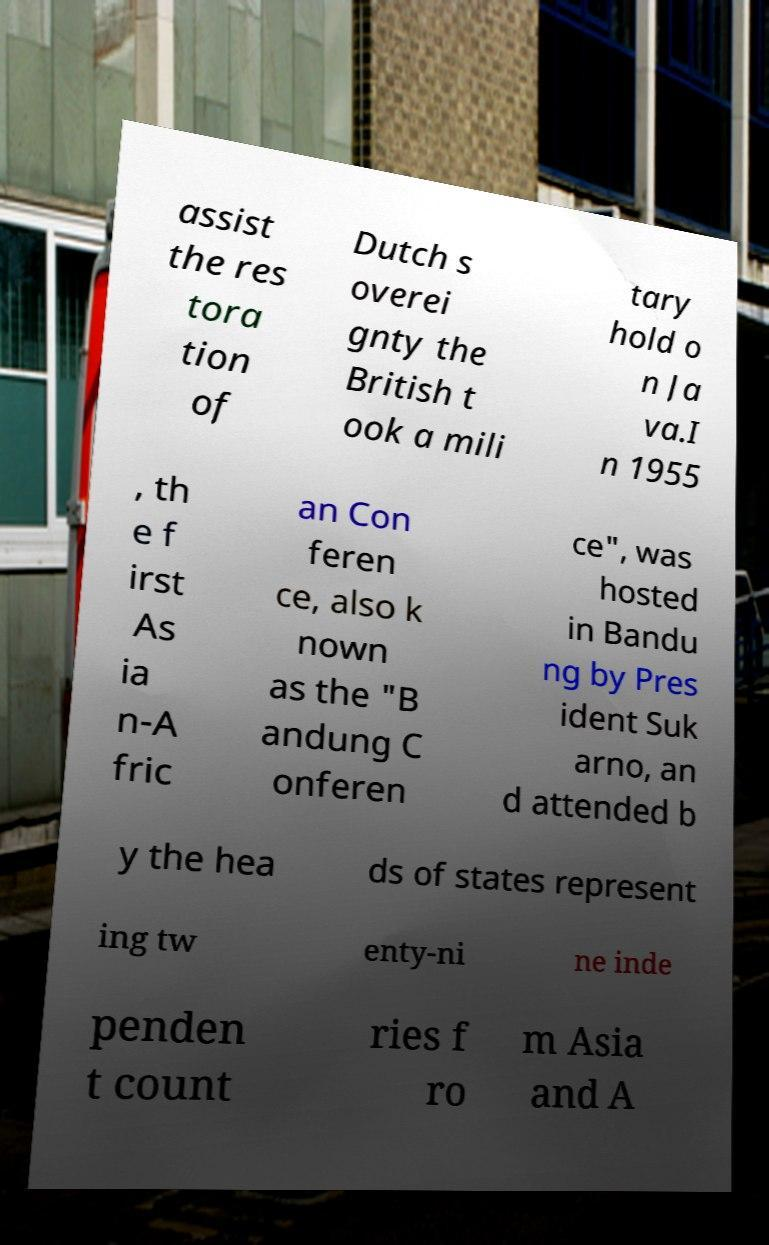Please identify and transcribe the text found in this image. assist the res tora tion of Dutch s overei gnty the British t ook a mili tary hold o n Ja va.I n 1955 , th e f irst As ia n-A fric an Con feren ce, also k nown as the "B andung C onferen ce", was hosted in Bandu ng by Pres ident Suk arno, an d attended b y the hea ds of states represent ing tw enty-ni ne inde penden t count ries f ro m Asia and A 